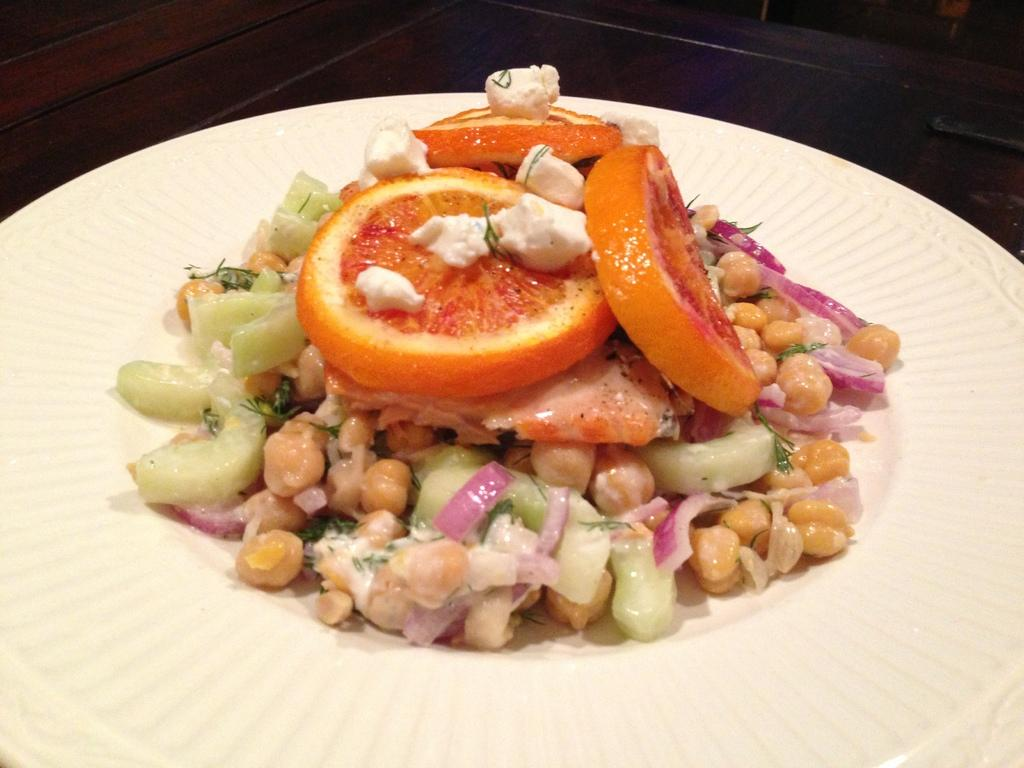What is on the plate in the image? There is food in the plate. Where is the plate located? The plate is on a wooden platform. What is the price of the cemetery in the image? There is no cemetery present in the image, so it is not possible to determine its price. 